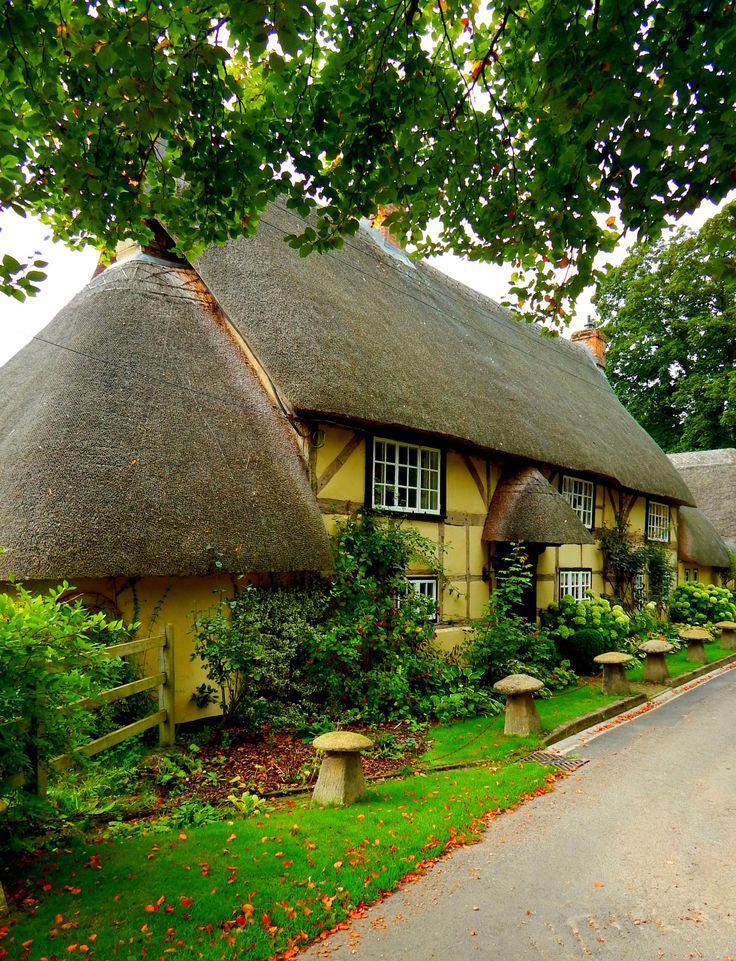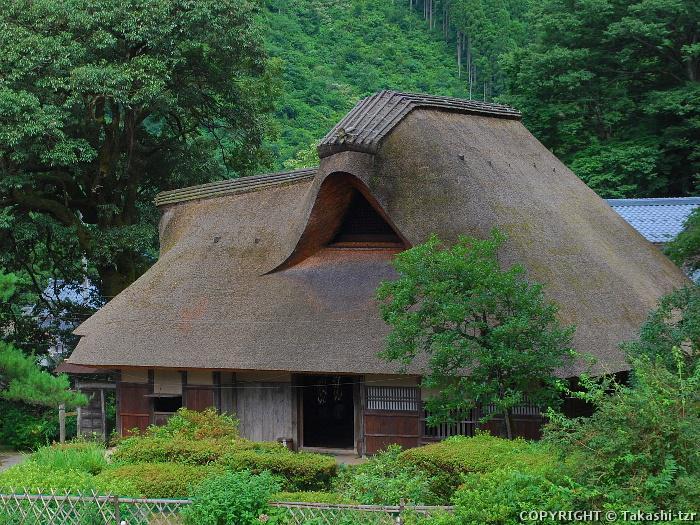The first image is the image on the left, the second image is the image on the right. Evaluate the accuracy of this statement regarding the images: "In at least one of the images you can see all the way through the house to the outside.". Is it true? Answer yes or no. No. 